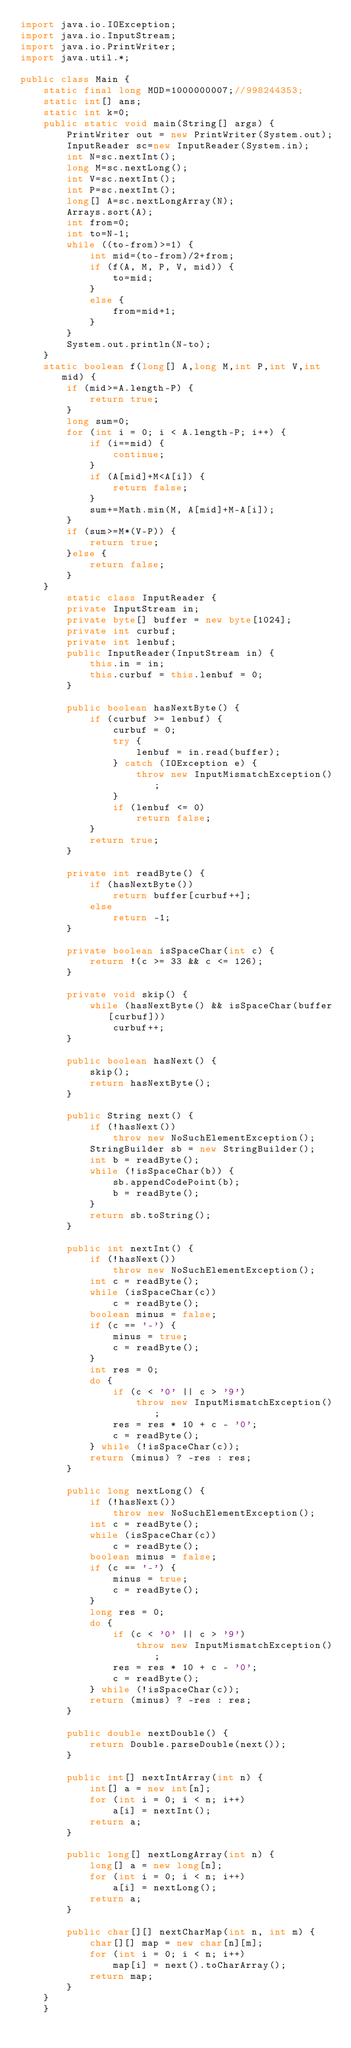<code> <loc_0><loc_0><loc_500><loc_500><_Java_>import java.io.IOException;
import java.io.InputStream;
import java.io.PrintWriter;
import java.util.*;

public class Main {
	static final long MOD=1000000007;//998244353;
	static int[] ans;
	static int k=0;
	public static void main(String[] args) {
		PrintWriter out = new PrintWriter(System.out);
		InputReader sc=new InputReader(System.in);
		int N=sc.nextInt();
		long M=sc.nextLong();
		int V=sc.nextInt();
		int P=sc.nextInt();
		long[] A=sc.nextLongArray(N);
		Arrays.sort(A);
		int from=0;
		int to=N-1;
		while ((to-from)>=1) {
			int mid=(to-from)/2+from;
			if (f(A, M, P, V, mid)) {
				to=mid;
			}
			else {
				from=mid+1;
			}
		}
		System.out.println(N-to);
 	}
	static boolean f(long[] A,long M,int P,int V,int mid) {
		if (mid>=A.length-P) {
			return true;
		}
		long sum=0;
		for (int i = 0; i < A.length-P; i++) {
			if (i==mid) {
				continue;
			}
			if (A[mid]+M<A[i]) {
				return false;
			}
			sum+=Math.min(M, A[mid]+M-A[i]);
		}
		if (sum>=M*(V-P)) {
			return true;
		}else {
			return false;
		}
	}
		static class InputReader { 
		private InputStream in;
		private byte[] buffer = new byte[1024];
		private int curbuf;
		private int lenbuf;
		public InputReader(InputStream in) {
			this.in = in;
			this.curbuf = this.lenbuf = 0;
		}
 
		public boolean hasNextByte() {
			if (curbuf >= lenbuf) {
				curbuf = 0;
				try {
					lenbuf = in.read(buffer);
				} catch (IOException e) {
					throw new InputMismatchException();
				}
				if (lenbuf <= 0)
					return false;
			}
			return true;
		}
 
		private int readByte() {
			if (hasNextByte())
				return buffer[curbuf++];
			else
				return -1;
		}
 
		private boolean isSpaceChar(int c) {
			return !(c >= 33 && c <= 126);
		}
 
		private void skip() {
			while (hasNextByte() && isSpaceChar(buffer[curbuf]))
				curbuf++;
		}
 
		public boolean hasNext() {
			skip();
			return hasNextByte();
		}
 
		public String next() {
			if (!hasNext())
				throw new NoSuchElementException();
			StringBuilder sb = new StringBuilder();
			int b = readByte();
			while (!isSpaceChar(b)) {
				sb.appendCodePoint(b);
				b = readByte();
			}
			return sb.toString();
		}
 
		public int nextInt() {
			if (!hasNext())
				throw new NoSuchElementException();
			int c = readByte();
			while (isSpaceChar(c))
				c = readByte();
			boolean minus = false;
			if (c == '-') {
				minus = true;
				c = readByte();
			}
			int res = 0;
			do {
				if (c < '0' || c > '9')
					throw new InputMismatchException();
				res = res * 10 + c - '0';
				c = readByte();
			} while (!isSpaceChar(c));
			return (minus) ? -res : res;
		}
 
		public long nextLong() {
			if (!hasNext())
				throw new NoSuchElementException();
			int c = readByte();
			while (isSpaceChar(c))
				c = readByte();
			boolean minus = false;
			if (c == '-') {
				minus = true;
				c = readByte();
			}
			long res = 0;
			do {
				if (c < '0' || c > '9')
					throw new InputMismatchException();
				res = res * 10 + c - '0';
				c = readByte();
			} while (!isSpaceChar(c));
			return (minus) ? -res : res;
		}
 
		public double nextDouble() {
			return Double.parseDouble(next());
		}
 
		public int[] nextIntArray(int n) {
			int[] a = new int[n];
			for (int i = 0; i < n; i++)
				a[i] = nextInt();
			return a;
		}
 
		public long[] nextLongArray(int n) {
			long[] a = new long[n];
			for (int i = 0; i < n; i++)
				a[i] = nextLong();
			return a;
		}
 
		public char[][] nextCharMap(int n, int m) {
			char[][] map = new char[n][m];
			for (int i = 0; i < n; i++)
				map[i] = next().toCharArray();
			return map;
		}
	}
	}
</code> 